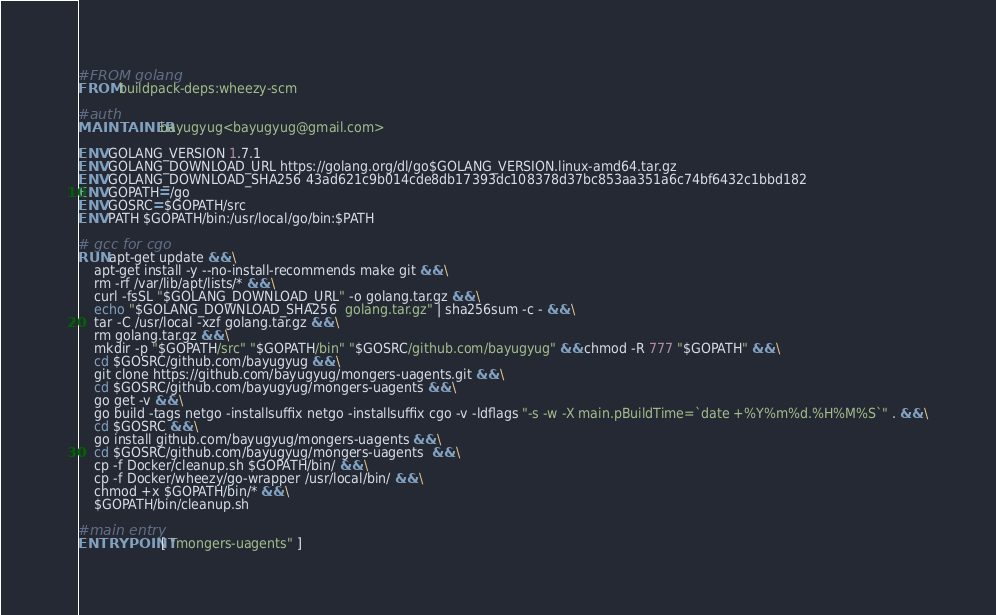<code> <loc_0><loc_0><loc_500><loc_500><_Dockerfile_>#FROM golang
FROM buildpack-deps:wheezy-scm

#auth
MAINTAINER bayugyug<bayugyug@gmail.com>

ENV GOLANG_VERSION 1.7.1
ENV GOLANG_DOWNLOAD_URL https://golang.org/dl/go$GOLANG_VERSION.linux-amd64.tar.gz
ENV GOLANG_DOWNLOAD_SHA256 43ad621c9b014cde8db17393dc108378d37bc853aa351a6c74bf6432c1bbd182
ENV GOPATH=/go
ENV GOSRC=$GOPATH/src
ENV PATH $GOPATH/bin:/usr/local/go/bin:$PATH

# gcc for cgo
RUN apt-get update && \
    apt-get install -y --no-install-recommends make git && \
	rm -rf /var/lib/apt/lists/* && \
    curl -fsSL "$GOLANG_DOWNLOAD_URL" -o golang.tar.gz && \
	echo "$GOLANG_DOWNLOAD_SHA256  golang.tar.gz" | sha256sum -c - && \
	tar -C /usr/local -xzf golang.tar.gz && \
	rm golang.tar.gz && \
    mkdir -p "$GOPATH/src" "$GOPATH/bin" "$GOSRC/github.com/bayugyug" && chmod -R 777 "$GOPATH" && \
    cd $GOSRC/github.com/bayugyug && \
    git clone https://github.com/bayugyug/mongers-uagents.git && \
    cd $GOSRC/github.com/bayugyug/mongers-uagents && \
    go get -v && \
    go build -tags netgo -installsuffix netgo -installsuffix cgo -v -ldflags "-s -w -X main.pBuildTime=`date +%Y%m%d.%H%M%S`" . && \
    cd $GOSRC && \
    go install github.com/bayugyug/mongers-uagents && \
    cd $GOSRC/github.com/bayugyug/mongers-uagents  && \
    cp -f Docker/cleanup.sh $GOPATH/bin/ && \
    cp -f Docker/wheezy/go-wrapper /usr/local/bin/ && \
    chmod +x $GOPATH/bin/* && \
    $GOPATH/bin/cleanup.sh

#main entry
ENTRYPOINT [ "mongers-uagents" ]
</code> 